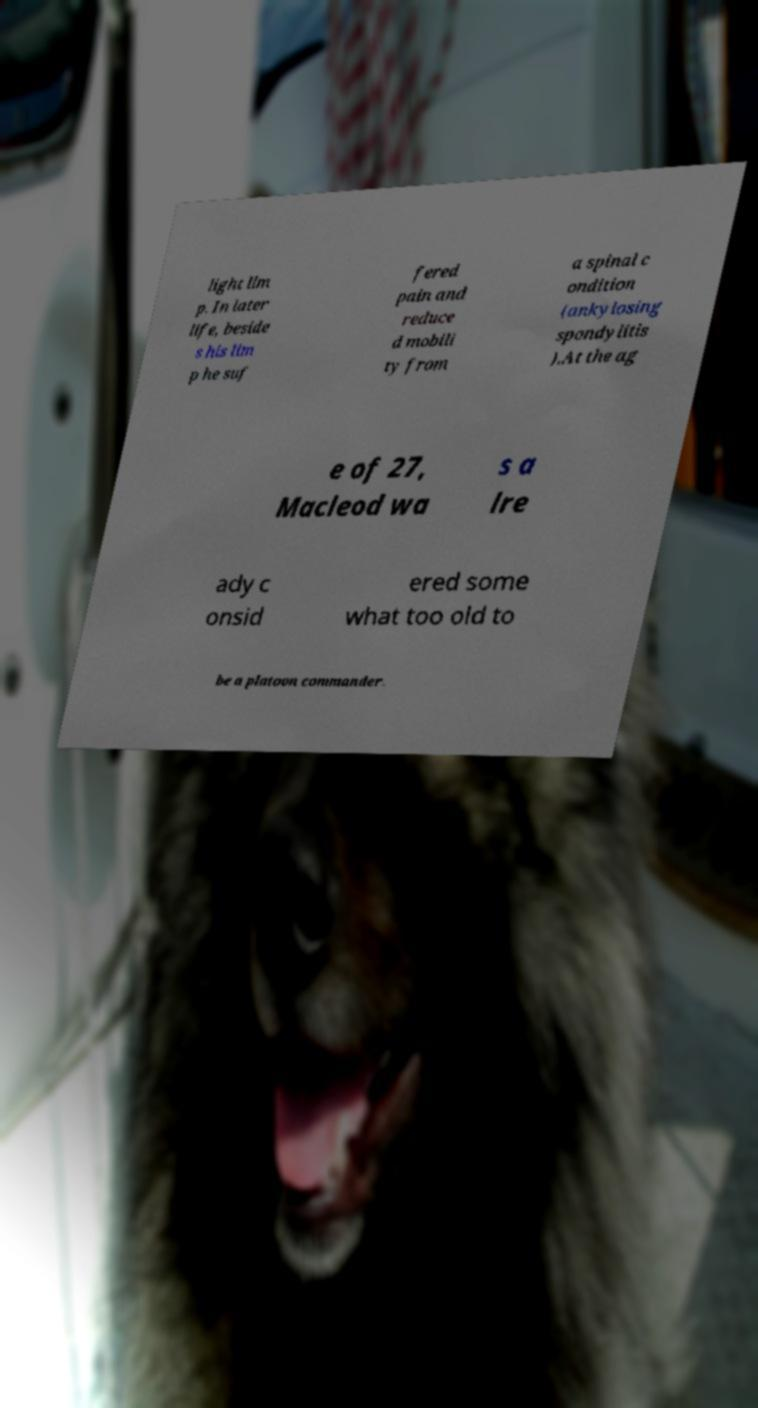There's text embedded in this image that I need extracted. Can you transcribe it verbatim? light lim p. In later life, beside s his lim p he suf fered pain and reduce d mobili ty from a spinal c ondition (ankylosing spondylitis ).At the ag e of 27, Macleod wa s a lre ady c onsid ered some what too old to be a platoon commander. 